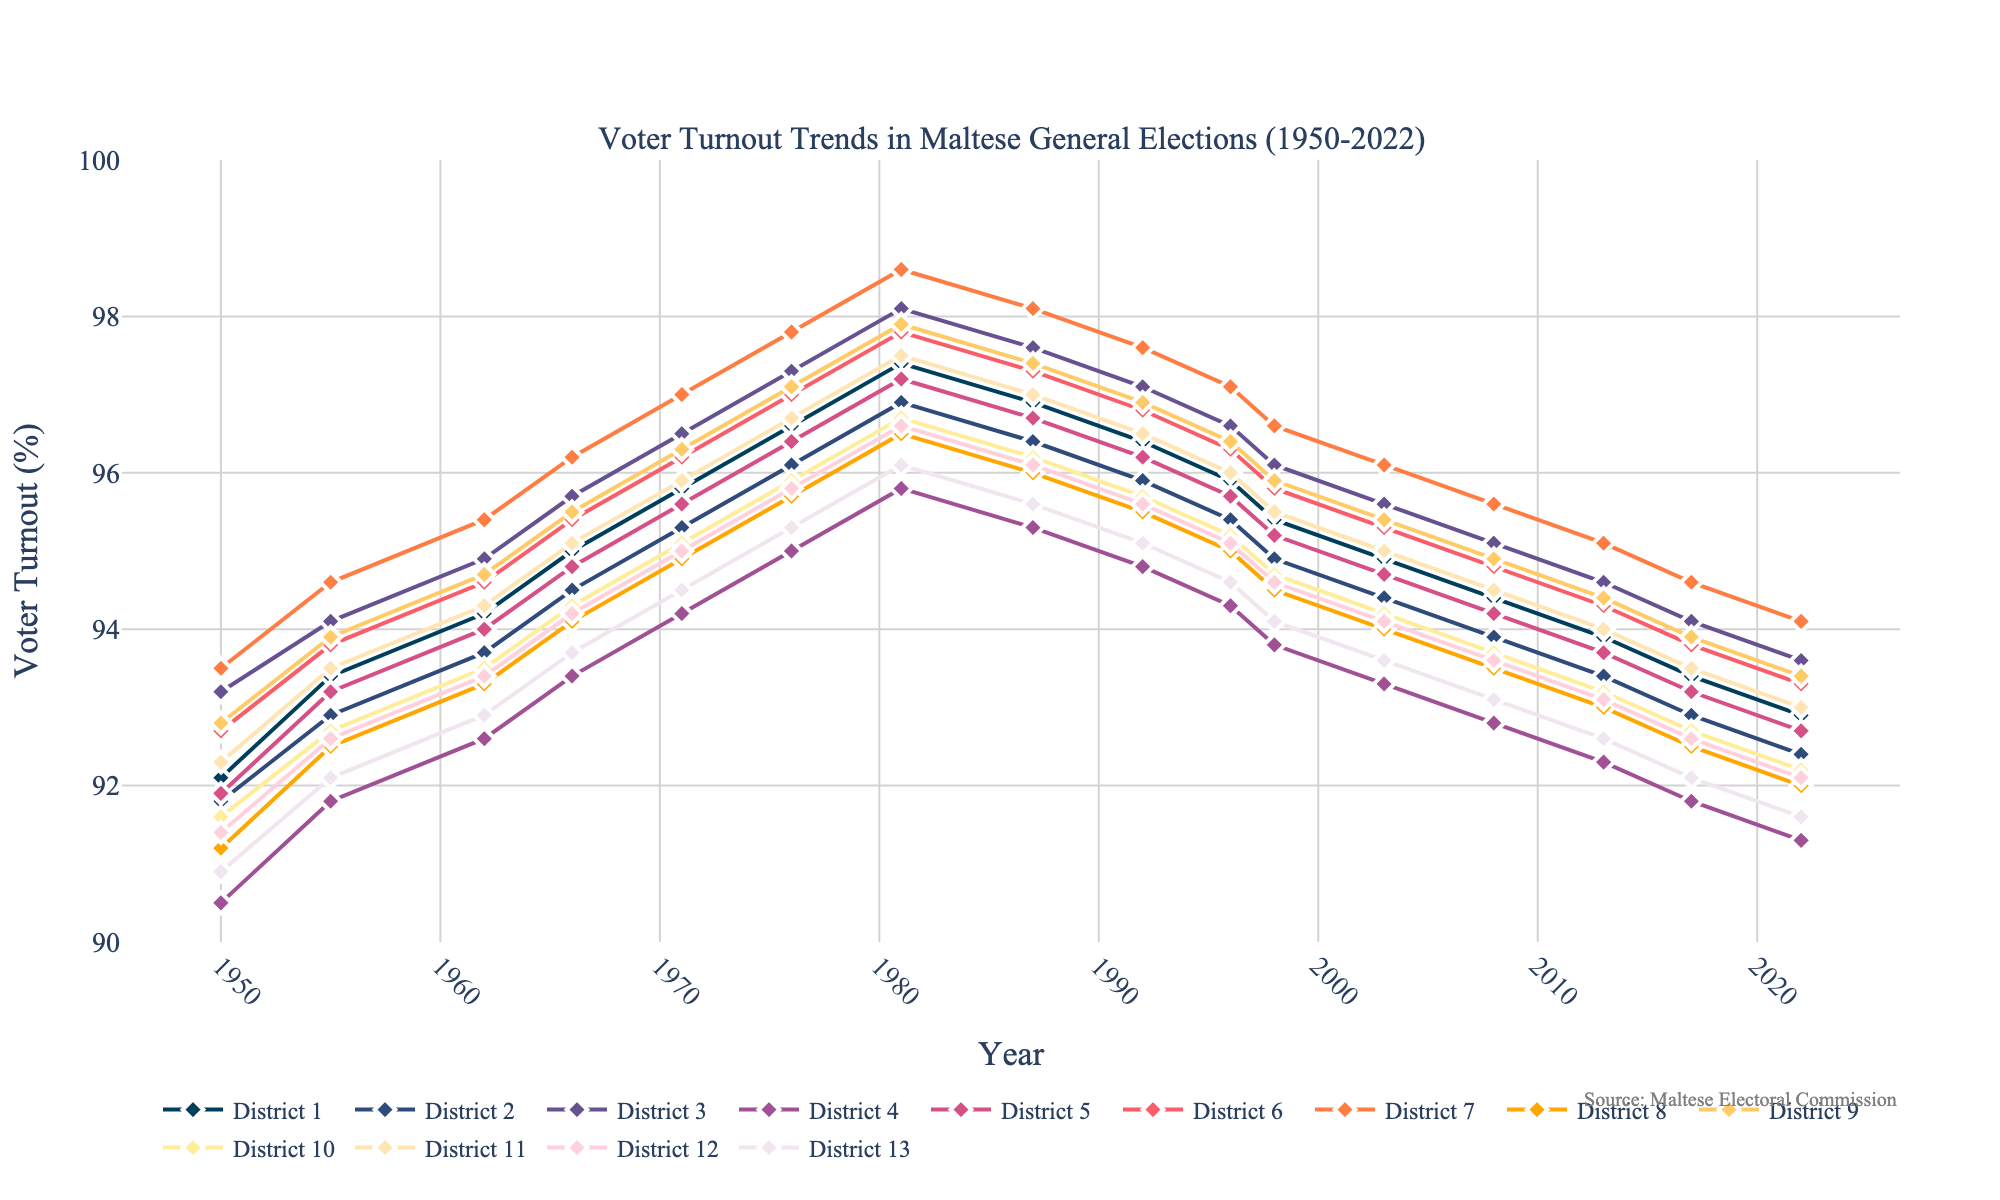Which district had the highest voter turnout in 1981? To find the district with the highest voter turnout in 1981, look at the data points for each district in that year. District 7 had the highest voter turnout with 98.6%.
Answer: District 7 How did the voter turnout in District 4 change from 1955 to 2022? Compare the voter turnout values for District 4 in 1955 and 2022. In 1955, it was 91.8%, and in 2022, it was 91.3%. Therefore, it slightly decreased by 0.5%.
Answer: Decreased by 0.5% Which two districts had the closest voter turnout in 2022, and what were their turnouts? In 2022, District 1 had a voter turnout of 92.9%, and District 8 had a voter turnout of 92.0%. The difference between these two is 0.9%, which is the smallest difference among all districts.
Answer: District 1 (92.9%) and District 8 (92.0%) Is there a district where voter turnout consistently decreased from 1981 to 2022? Observe the voter turnout trend lines from 1981 to 2022. District 10 shows a consistent decrease in voter turnout from 96.7% in 1981 to 92.2% in 2022.
Answer: District 10 What was the average voter turnout across all districts in 1971? Add the voter turnout percentages for all districts in 1971 and divide by the number of districts (13). The sum is 95.67, so the average is 95.67/13 ≈ 95.6%.
Answer: 95.6% Between which consecutive general elections did District 7 see the largest drop in voter turnout? Check the differences in consecutive election years for District 7. The largest drop occurred between 1981 (98.6%) and 1987 (98.1%), dropping by 0.5%.
Answer: Between 1981 and 1987 What is the overall trend in voter turnout for District 9 from 1950 to 2022? Observe the trend line for District 9 from 1950 to 2022. The voter turnout for District 9 slightly decreased from 92.8% in 1950 to 93.4% in 2022, indicating a slight increase overall.
Answer: Increasing Which district had the lowest voter turnout in 2003, and what was the value? For the year 2003, compare the voter turnouts for all districts. District 4 had the lowest voter turnout with 93.3%.
Answer: District 4 (93.3%) How does the voter turnout in District 6 in 1966 compare to the average voter turnout in 1966 across all districts? First, find the voter turnout for District 6 in 1966, which is 95.4%. Then, calculate the average voter turnout across all districts in 1966. The average voter turnout is 94.7%. Since 95.4% is greater than 94.7%, District 6 has a higher turnout than the average.
Answer: Higher than the average What was the increase in voter turnout for District 3 from 1950 to 1966? Compare voter turnout for District 3 in 1950 and 1966. In 1950, it was 93.2%, and in 1966, it was 95.7%. The increase is 95.7% - 93.2% = 2.5%.
Answer: Increased by 2.5% 